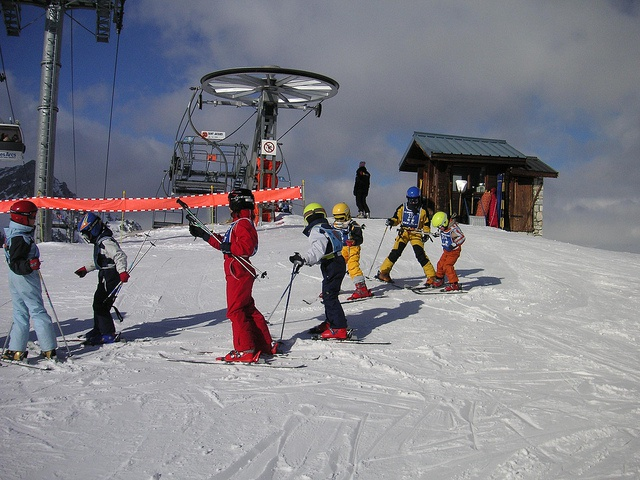Describe the objects in this image and their specific colors. I can see people in black, darkgray, and gray tones, people in black, brown, maroon, and darkgray tones, people in black, darkgray, gray, and lightgray tones, people in black, darkgray, gray, and navy tones, and people in black, olive, and darkgray tones in this image. 